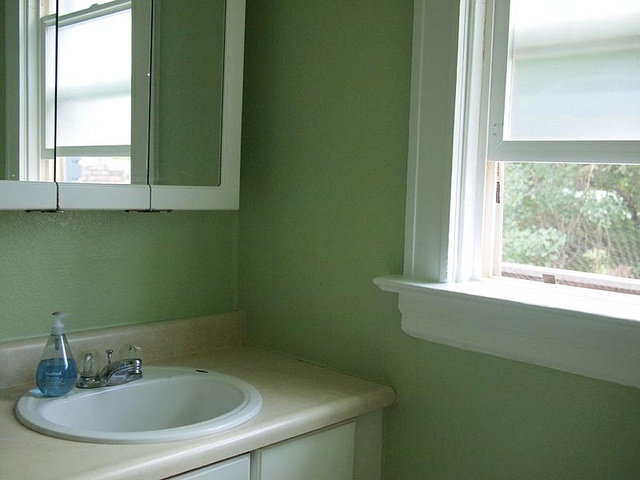Describe the objects in this image and their specific colors. I can see sink in darkgreen, darkgray, and gray tones and bottle in darkgreen, blue, and gray tones in this image. 